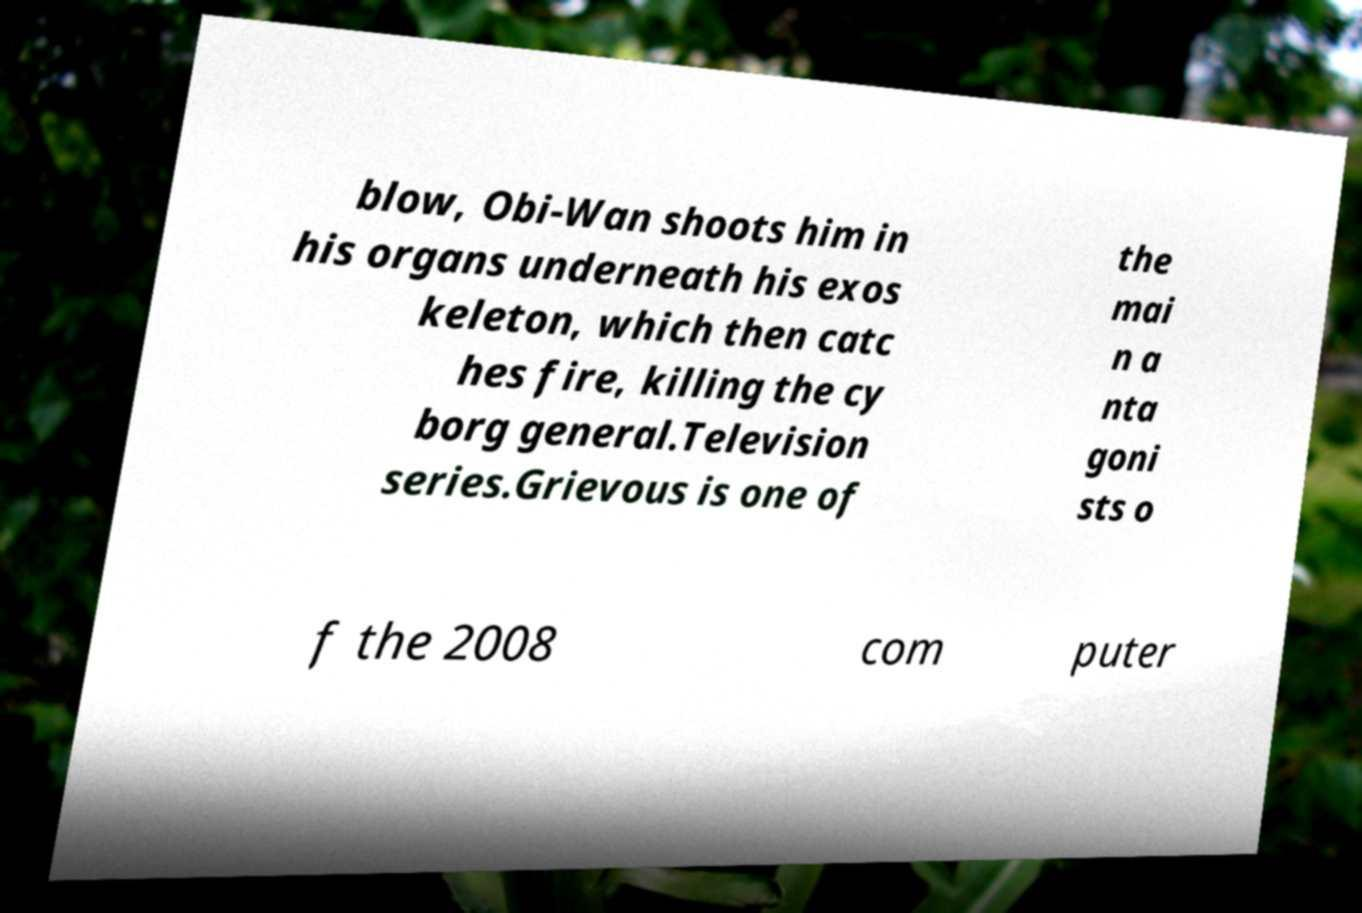Please read and relay the text visible in this image. What does it say? blow, Obi-Wan shoots him in his organs underneath his exos keleton, which then catc hes fire, killing the cy borg general.Television series.Grievous is one of the mai n a nta goni sts o f the 2008 com puter 